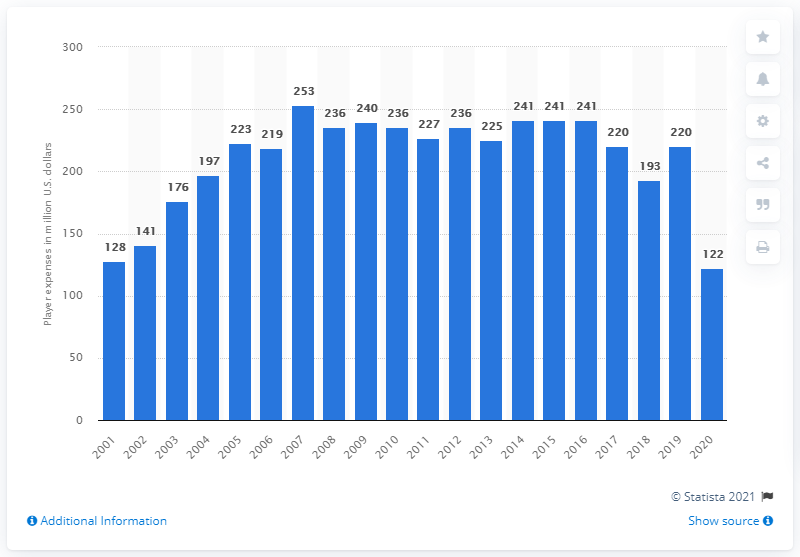Give some essential details in this illustration. The payroll of the New York Yankees in 2020 was 122 million dollars. 